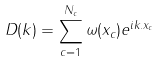<formula> <loc_0><loc_0><loc_500><loc_500>D ( { k } ) = \sum ^ { N _ { c } } _ { c = 1 } \omega ( x _ { c } ) e ^ { i { k } . { x } _ { c } }</formula> 